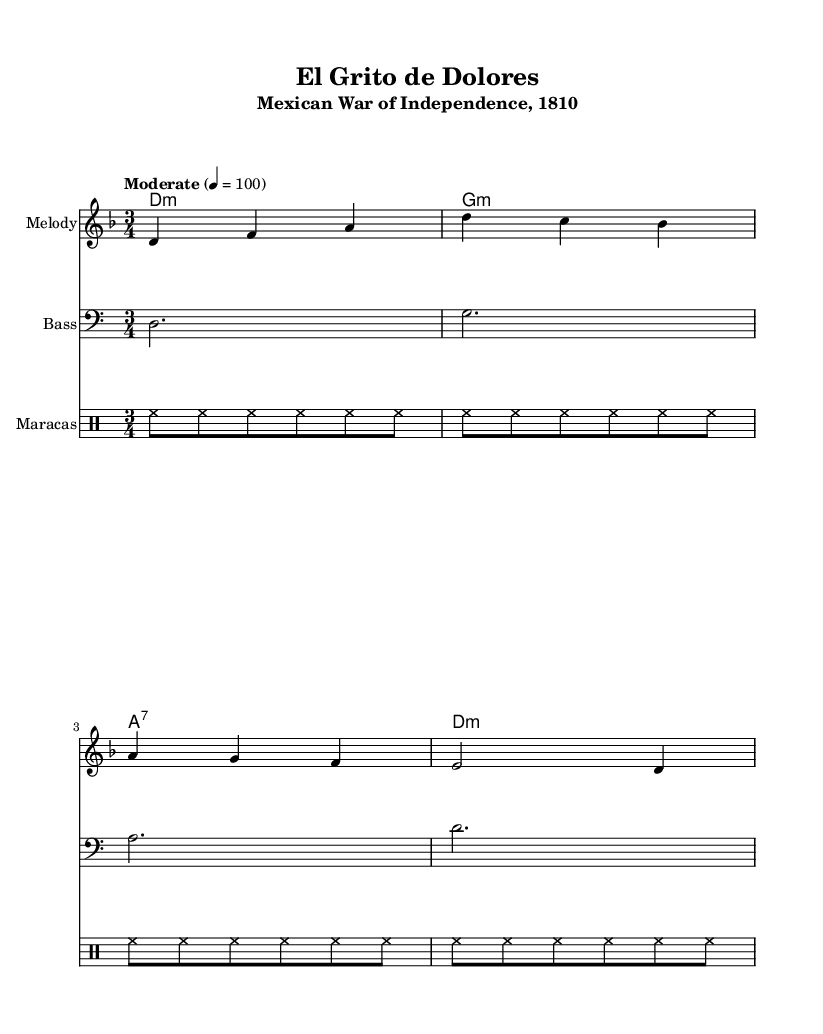What is the time signature of this music? The time signature is indicated at the beginning of the sheet music with a "3/4," meaning there are three beats per measure, and the quarter note gets one beat.
Answer: 3/4 What is the key signature of this music? The key signature shows two flats (B♭ and E♭), indicating that this piece is in D minor.
Answer: D minor What is the tempo marking for this piece? The tempo marking appears above the staff and specifies "Moderate" with a metronome marking of 4 = 100, meaning that there are 100 beats per minute.
Answer: Moderate How many measures are there in the melody? Counting the bars in the melody section, there are a total of four measures in the given melody line.
Answer: 4 What type of rhythm is used by the maracas? The maracas rhythm is indicated using a repeated pattern that utilizes "hh," which represents a hi-hat sound played repeatedly, occurring four times in total.
Answer: Hi-hat rhythm What historical event does this piece represent? The header of the sheet music specifies that this piece is titled "El Grito de Dolores," which was a significant event marking the start of the Mexican War of Independence in 1810.
Answer: Mexican War of Independence What is the role of the bass in this music? The bass line, indicated in a separate staff, provides a harmonic foundation by playing the root notes of the chords and complementing the melody above it.
Answer: Harmonic foundation 